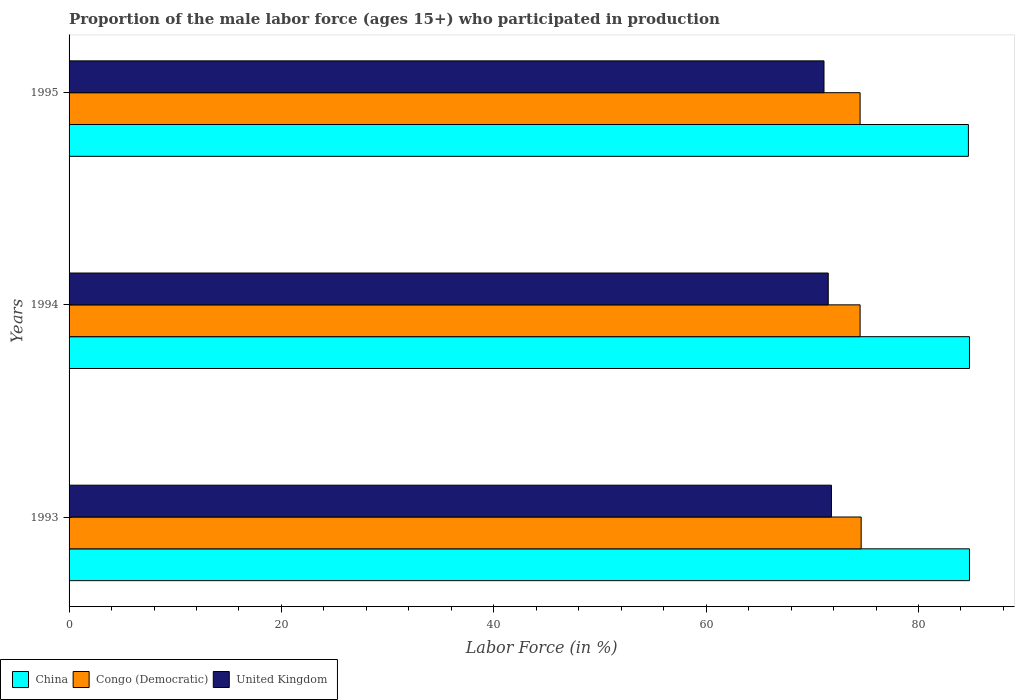How many different coloured bars are there?
Provide a short and direct response. 3. Are the number of bars per tick equal to the number of legend labels?
Ensure brevity in your answer.  Yes. How many bars are there on the 2nd tick from the top?
Make the answer very short. 3. What is the proportion of the male labor force who participated in production in United Kingdom in 1994?
Your response must be concise. 71.5. Across all years, what is the maximum proportion of the male labor force who participated in production in United Kingdom?
Your response must be concise. 71.8. Across all years, what is the minimum proportion of the male labor force who participated in production in United Kingdom?
Offer a terse response. 71.1. In which year was the proportion of the male labor force who participated in production in China maximum?
Keep it short and to the point. 1993. In which year was the proportion of the male labor force who participated in production in Congo (Democratic) minimum?
Provide a short and direct response. 1994. What is the total proportion of the male labor force who participated in production in United Kingdom in the graph?
Provide a short and direct response. 214.4. What is the difference between the proportion of the male labor force who participated in production in China in 1994 and that in 1995?
Provide a short and direct response. 0.1. What is the difference between the proportion of the male labor force who participated in production in United Kingdom in 1994 and the proportion of the male labor force who participated in production in Congo (Democratic) in 1995?
Your answer should be compact. -3. What is the average proportion of the male labor force who participated in production in United Kingdom per year?
Ensure brevity in your answer.  71.47. In the year 1994, what is the difference between the proportion of the male labor force who participated in production in China and proportion of the male labor force who participated in production in United Kingdom?
Your response must be concise. 13.3. What is the ratio of the proportion of the male labor force who participated in production in China in 1993 to that in 1994?
Give a very brief answer. 1. What is the difference between the highest and the second highest proportion of the male labor force who participated in production in China?
Give a very brief answer. 0. What is the difference between the highest and the lowest proportion of the male labor force who participated in production in China?
Offer a terse response. 0.1. What does the 2nd bar from the top in 1994 represents?
Provide a short and direct response. Congo (Democratic). What does the 1st bar from the bottom in 1993 represents?
Make the answer very short. China. How many bars are there?
Your answer should be very brief. 9. Are the values on the major ticks of X-axis written in scientific E-notation?
Keep it short and to the point. No. Where does the legend appear in the graph?
Give a very brief answer. Bottom left. How are the legend labels stacked?
Make the answer very short. Horizontal. What is the title of the graph?
Provide a succinct answer. Proportion of the male labor force (ages 15+) who participated in production. Does "Kiribati" appear as one of the legend labels in the graph?
Provide a succinct answer. No. What is the label or title of the X-axis?
Keep it short and to the point. Labor Force (in %). What is the Labor Force (in %) in China in 1993?
Your response must be concise. 84.8. What is the Labor Force (in %) of Congo (Democratic) in 1993?
Keep it short and to the point. 74.6. What is the Labor Force (in %) in United Kingdom in 1993?
Offer a very short reply. 71.8. What is the Labor Force (in %) of China in 1994?
Your response must be concise. 84.8. What is the Labor Force (in %) of Congo (Democratic) in 1994?
Give a very brief answer. 74.5. What is the Labor Force (in %) in United Kingdom in 1994?
Keep it short and to the point. 71.5. What is the Labor Force (in %) in China in 1995?
Your response must be concise. 84.7. What is the Labor Force (in %) in Congo (Democratic) in 1995?
Ensure brevity in your answer.  74.5. What is the Labor Force (in %) in United Kingdom in 1995?
Offer a very short reply. 71.1. Across all years, what is the maximum Labor Force (in %) of China?
Your answer should be very brief. 84.8. Across all years, what is the maximum Labor Force (in %) of Congo (Democratic)?
Offer a very short reply. 74.6. Across all years, what is the maximum Labor Force (in %) of United Kingdom?
Provide a succinct answer. 71.8. Across all years, what is the minimum Labor Force (in %) of China?
Your answer should be very brief. 84.7. Across all years, what is the minimum Labor Force (in %) of Congo (Democratic)?
Make the answer very short. 74.5. Across all years, what is the minimum Labor Force (in %) in United Kingdom?
Provide a short and direct response. 71.1. What is the total Labor Force (in %) of China in the graph?
Your answer should be compact. 254.3. What is the total Labor Force (in %) in Congo (Democratic) in the graph?
Provide a short and direct response. 223.6. What is the total Labor Force (in %) in United Kingdom in the graph?
Keep it short and to the point. 214.4. What is the difference between the Labor Force (in %) in Congo (Democratic) in 1993 and that in 1994?
Your response must be concise. 0.1. What is the difference between the Labor Force (in %) in United Kingdom in 1993 and that in 1994?
Your answer should be very brief. 0.3. What is the difference between the Labor Force (in %) of China in 1993 and that in 1995?
Offer a terse response. 0.1. What is the difference between the Labor Force (in %) in Congo (Democratic) in 1993 and that in 1995?
Offer a very short reply. 0.1. What is the difference between the Labor Force (in %) of China in 1994 and that in 1995?
Give a very brief answer. 0.1. What is the difference between the Labor Force (in %) in Congo (Democratic) in 1994 and that in 1995?
Provide a short and direct response. 0. What is the difference between the Labor Force (in %) in China in 1993 and the Labor Force (in %) in Congo (Democratic) in 1994?
Offer a very short reply. 10.3. What is the difference between the Labor Force (in %) of Congo (Democratic) in 1993 and the Labor Force (in %) of United Kingdom in 1994?
Your answer should be very brief. 3.1. What is the difference between the Labor Force (in %) in China in 1993 and the Labor Force (in %) in Congo (Democratic) in 1995?
Provide a short and direct response. 10.3. What is the difference between the Labor Force (in %) of China in 1993 and the Labor Force (in %) of United Kingdom in 1995?
Provide a succinct answer. 13.7. What is the difference between the Labor Force (in %) in China in 1994 and the Labor Force (in %) in United Kingdom in 1995?
Provide a short and direct response. 13.7. What is the average Labor Force (in %) in China per year?
Ensure brevity in your answer.  84.77. What is the average Labor Force (in %) in Congo (Democratic) per year?
Keep it short and to the point. 74.53. What is the average Labor Force (in %) in United Kingdom per year?
Your answer should be compact. 71.47. In the year 1994, what is the difference between the Labor Force (in %) of Congo (Democratic) and Labor Force (in %) of United Kingdom?
Offer a very short reply. 3. In the year 1995, what is the difference between the Labor Force (in %) in Congo (Democratic) and Labor Force (in %) in United Kingdom?
Provide a short and direct response. 3.4. What is the ratio of the Labor Force (in %) of Congo (Democratic) in 1993 to that in 1994?
Your answer should be very brief. 1. What is the ratio of the Labor Force (in %) of United Kingdom in 1993 to that in 1994?
Ensure brevity in your answer.  1. What is the ratio of the Labor Force (in %) of Congo (Democratic) in 1993 to that in 1995?
Offer a terse response. 1. What is the ratio of the Labor Force (in %) in United Kingdom in 1993 to that in 1995?
Your response must be concise. 1.01. What is the ratio of the Labor Force (in %) of China in 1994 to that in 1995?
Your answer should be very brief. 1. What is the ratio of the Labor Force (in %) of Congo (Democratic) in 1994 to that in 1995?
Your answer should be compact. 1. What is the ratio of the Labor Force (in %) of United Kingdom in 1994 to that in 1995?
Make the answer very short. 1.01. What is the difference between the highest and the second highest Labor Force (in %) in China?
Provide a succinct answer. 0. What is the difference between the highest and the second highest Labor Force (in %) of Congo (Democratic)?
Your response must be concise. 0.1. What is the difference between the highest and the second highest Labor Force (in %) in United Kingdom?
Keep it short and to the point. 0.3. What is the difference between the highest and the lowest Labor Force (in %) in China?
Make the answer very short. 0.1. What is the difference between the highest and the lowest Labor Force (in %) in United Kingdom?
Your answer should be compact. 0.7. 